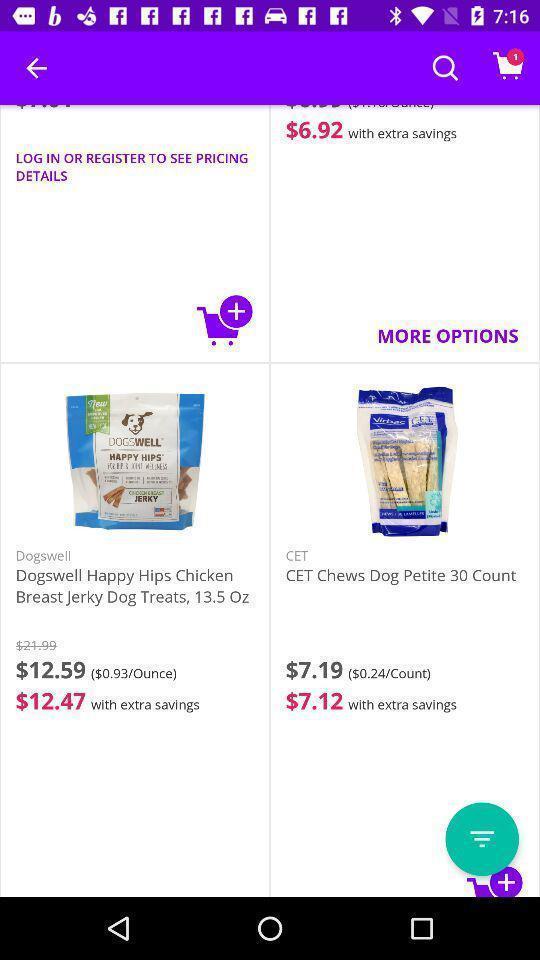Tell me what you see in this picture. Screen shows list of items in a shopping app. 